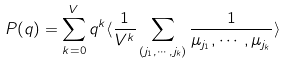Convert formula to latex. <formula><loc_0><loc_0><loc_500><loc_500>P ( q ) = \sum _ { k = 0 } ^ { V } q ^ { k } \langle \frac { 1 } { V ^ { k } } \sum _ { \left ( j _ { 1 } , \cdots , j _ { k } \right ) } \frac { 1 } { \mu _ { j _ { 1 } } , \cdots , \mu _ { j _ { k } } } \rangle</formula> 